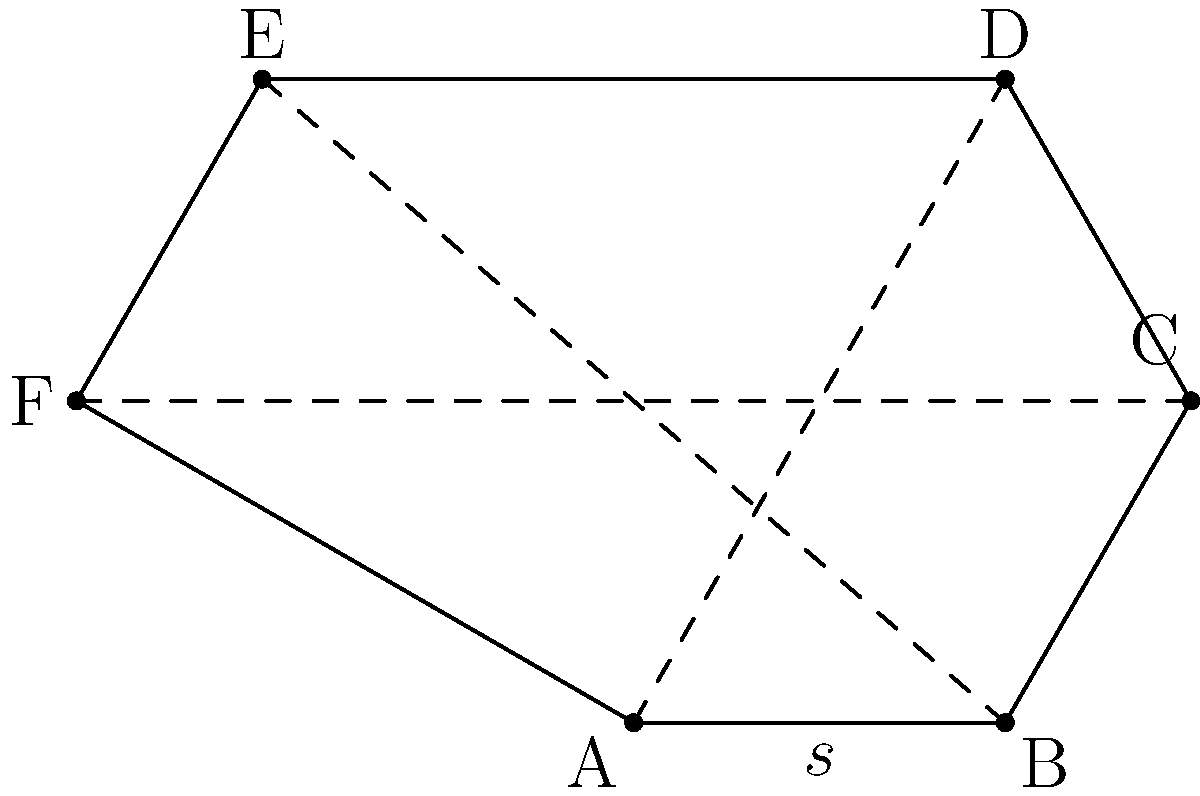A hexagonal bolt head used in a mechanical system has a side length of 10 mm. Calculate the perimeter of the bolt head. To calculate the perimeter of a regular hexagon, we need to follow these steps:

1. Identify the given information:
   - The hexagon has 6 equal sides
   - Each side length $s = 10$ mm

2. Recall the formula for the perimeter of a regular polygon:
   $$ \text{Perimeter} = \text{number of sides} \times \text{side length} $$

3. Substitute the values into the formula:
   $$ \text{Perimeter} = 6 \times 10 \text{ mm} $$

4. Perform the calculation:
   $$ \text{Perimeter} = 60 \text{ mm} $$

Therefore, the perimeter of the hexagonal bolt head is 60 mm.
Answer: 60 mm 